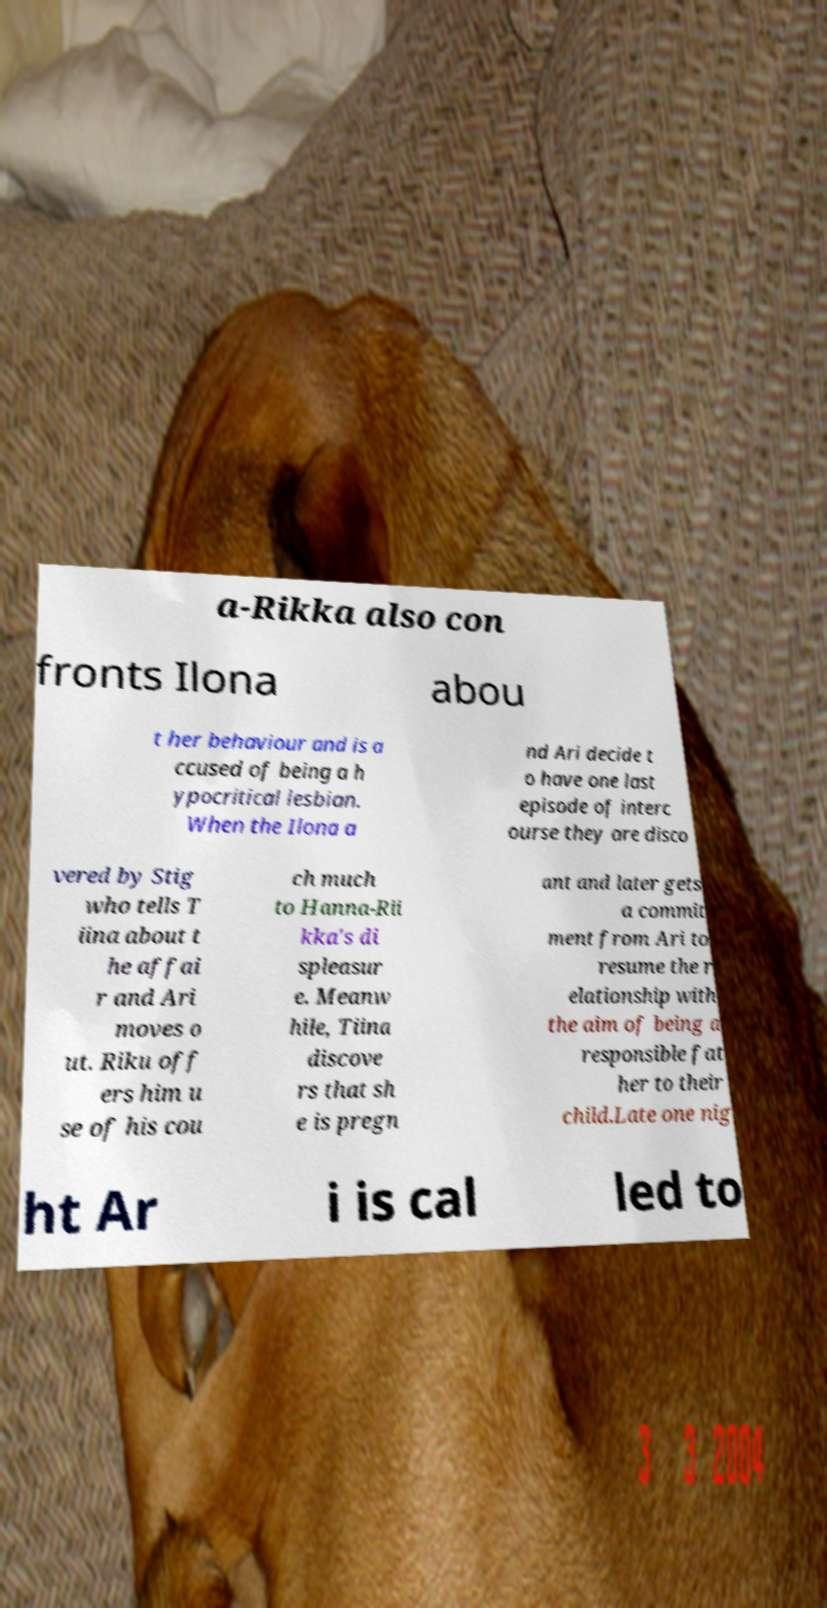What messages or text are displayed in this image? I need them in a readable, typed format. a-Rikka also con fronts Ilona abou t her behaviour and is a ccused of being a h ypocritical lesbian. When the Ilona a nd Ari decide t o have one last episode of interc ourse they are disco vered by Stig who tells T iina about t he affai r and Ari moves o ut. Riku off ers him u se of his cou ch much to Hanna-Rii kka's di spleasur e. Meanw hile, Tiina discove rs that sh e is pregn ant and later gets a commit ment from Ari to resume the r elationship with the aim of being a responsible fat her to their child.Late one nig ht Ar i is cal led to 